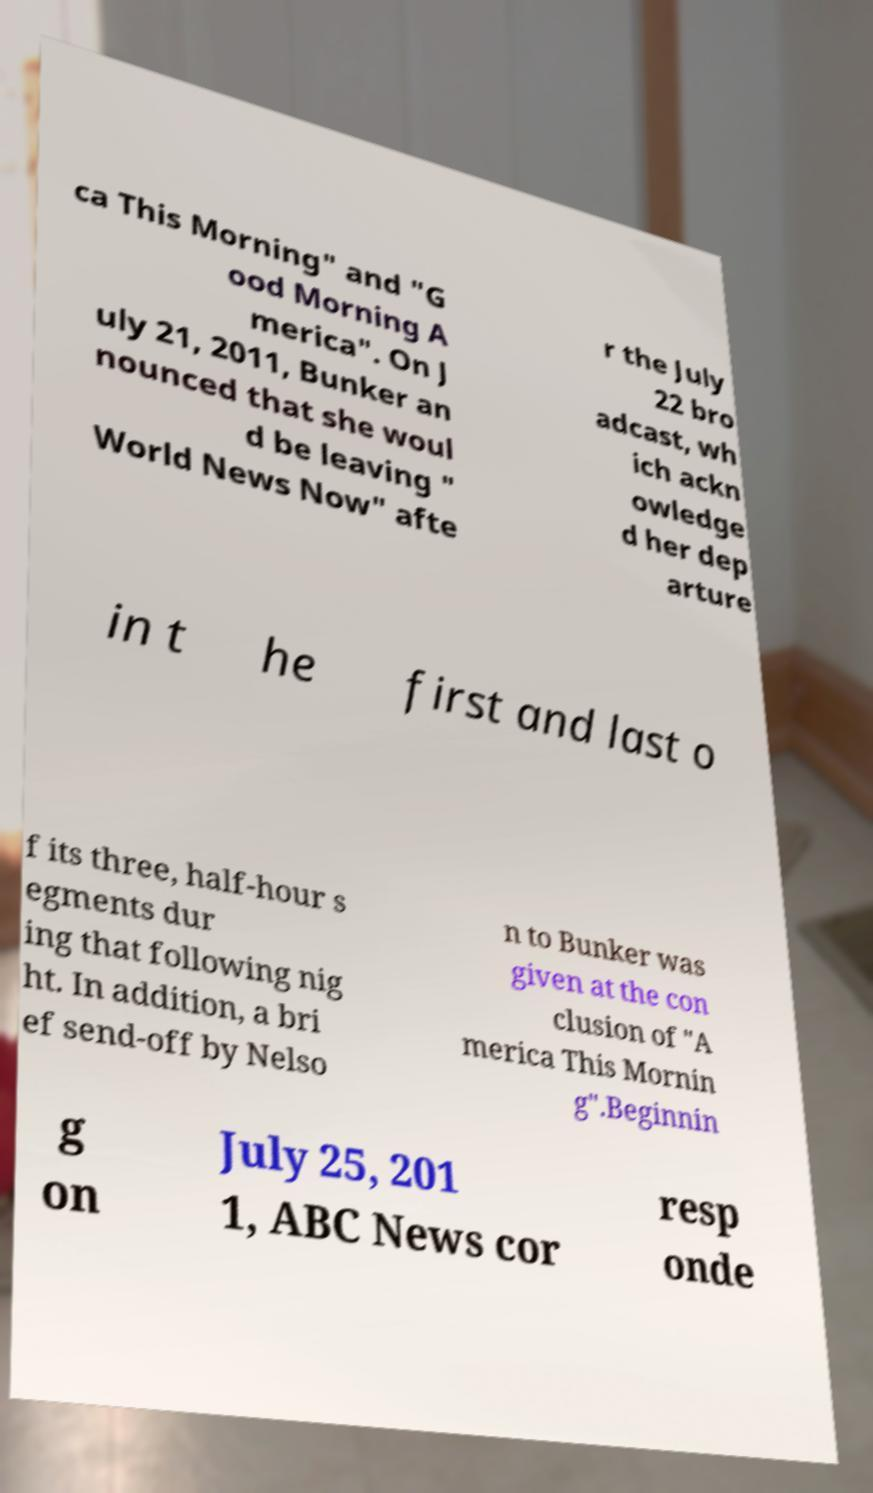Could you extract and type out the text from this image? ca This Morning" and "G ood Morning A merica". On J uly 21, 2011, Bunker an nounced that she woul d be leaving " World News Now" afte r the July 22 bro adcast, wh ich ackn owledge d her dep arture in t he first and last o f its three, half-hour s egments dur ing that following nig ht. In addition, a bri ef send-off by Nelso n to Bunker was given at the con clusion of "A merica This Mornin g".Beginnin g on July 25, 201 1, ABC News cor resp onde 